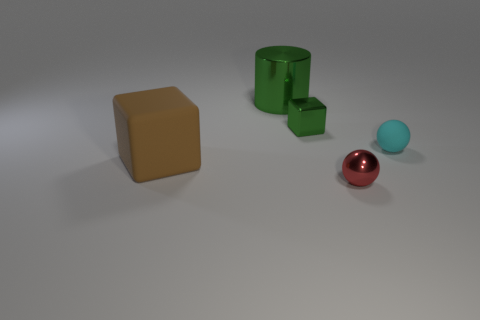Add 1 large gray rubber blocks. How many objects exist? 6 Subtract 0 cyan cubes. How many objects are left? 5 Subtract all cylinders. How many objects are left? 4 Subtract all tiny spheres. Subtract all brown things. How many objects are left? 2 Add 3 large metal cylinders. How many large metal cylinders are left? 4 Add 1 brown matte cubes. How many brown matte cubes exist? 2 